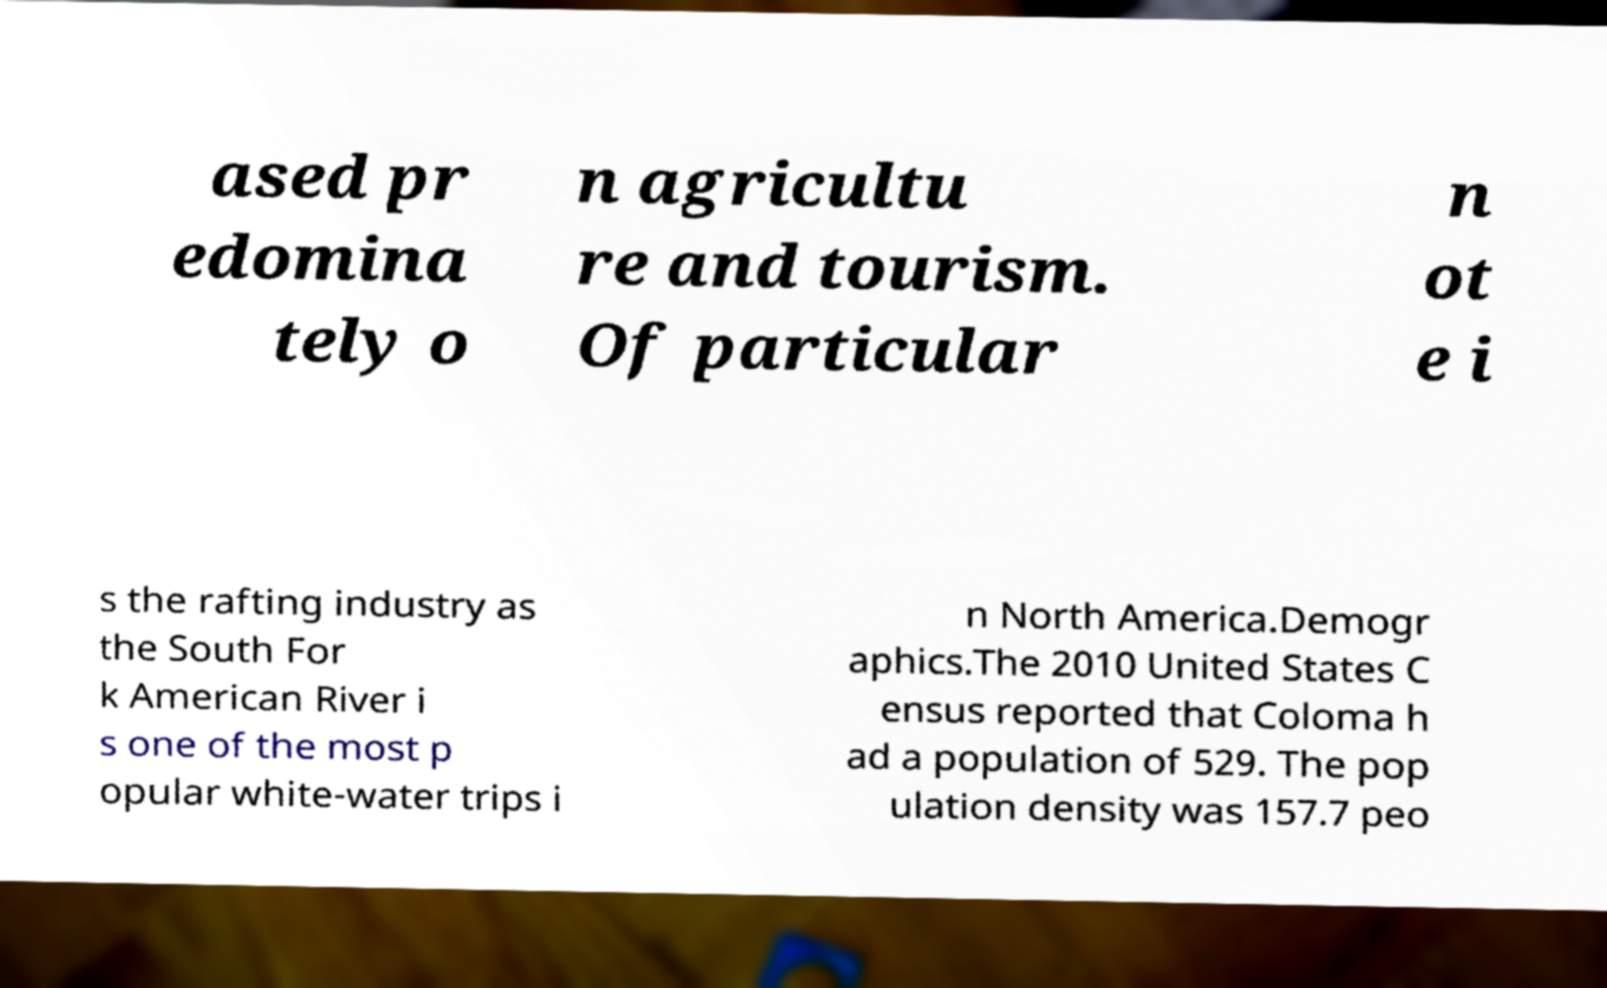Could you assist in decoding the text presented in this image and type it out clearly? ased pr edomina tely o n agricultu re and tourism. Of particular n ot e i s the rafting industry as the South For k American River i s one of the most p opular white-water trips i n North America.Demogr aphics.The 2010 United States C ensus reported that Coloma h ad a population of 529. The pop ulation density was 157.7 peo 